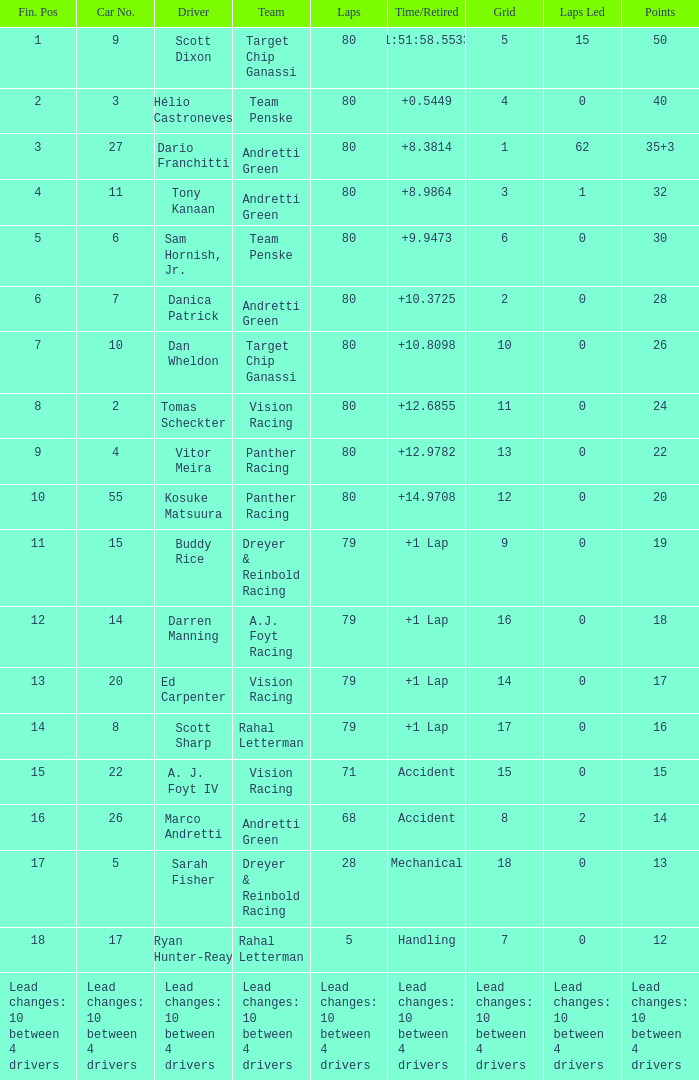How many points does driver kosuke matsuura have? 20.0. 